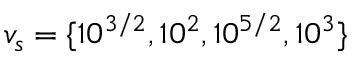Convert formula to latex. <formula><loc_0><loc_0><loc_500><loc_500>v _ { s } = \{ 1 0 ^ { 3 / 2 } , 1 0 ^ { 2 } , 1 0 ^ { 5 / 2 } , 1 0 ^ { 3 } \}</formula> 